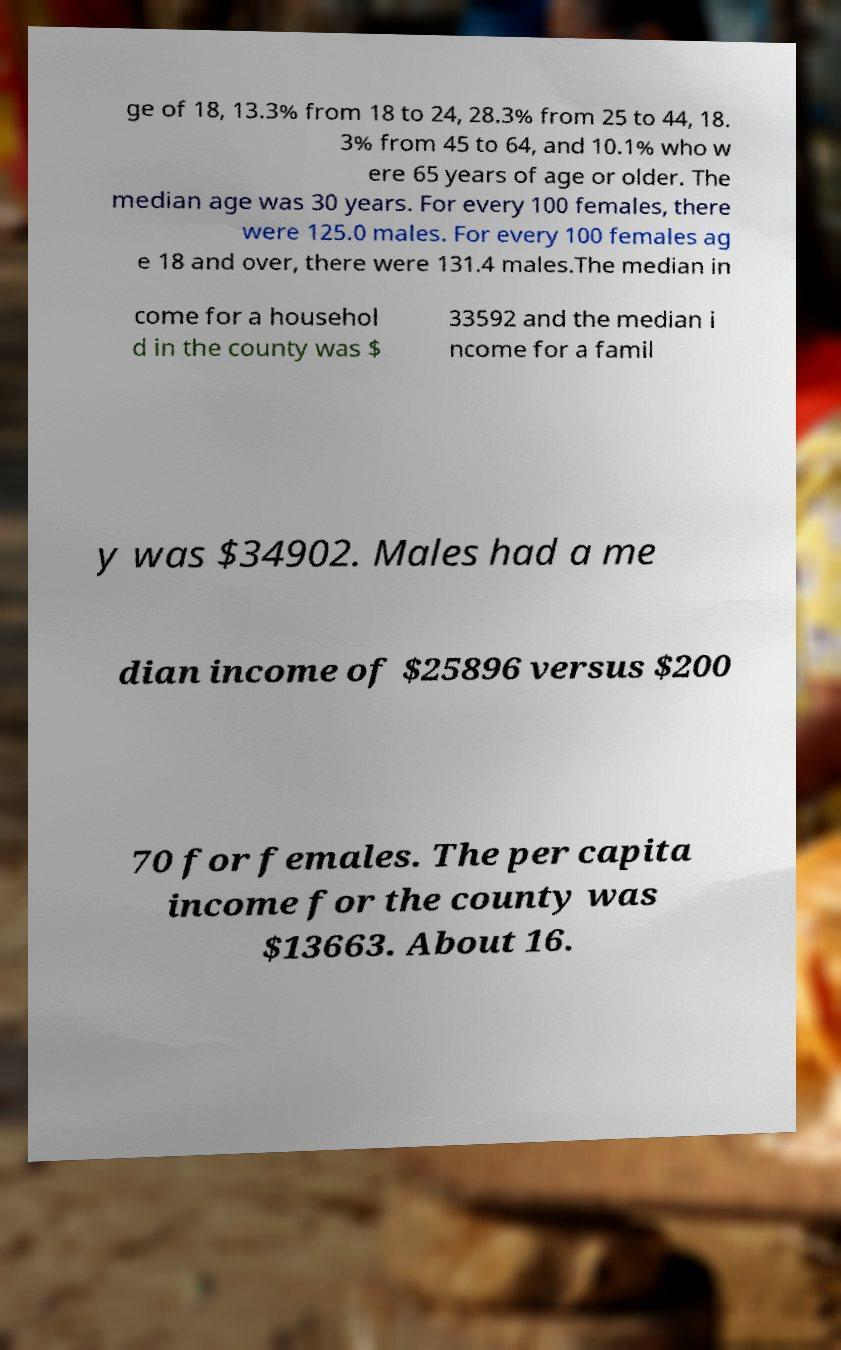There's text embedded in this image that I need extracted. Can you transcribe it verbatim? ge of 18, 13.3% from 18 to 24, 28.3% from 25 to 44, 18. 3% from 45 to 64, and 10.1% who w ere 65 years of age or older. The median age was 30 years. For every 100 females, there were 125.0 males. For every 100 females ag e 18 and over, there were 131.4 males.The median in come for a househol d in the county was $ 33592 and the median i ncome for a famil y was $34902. Males had a me dian income of $25896 versus $200 70 for females. The per capita income for the county was $13663. About 16. 